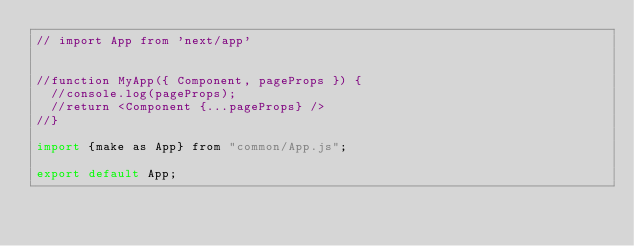Convert code to text. <code><loc_0><loc_0><loc_500><loc_500><_JavaScript_>// import App from 'next/app'


//function MyApp({ Component, pageProps }) {
  //console.log(pageProps);
  //return <Component {...pageProps} />
//}

import {make as App} from "common/App.js";

export default App;
</code> 